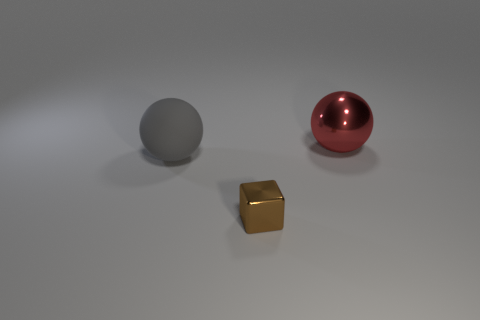Add 2 matte objects. How many objects exist? 5 Subtract all cubes. How many objects are left? 2 Add 3 small purple objects. How many small purple objects exist? 3 Subtract 0 cyan balls. How many objects are left? 3 Subtract all large gray spheres. Subtract all yellow metal spheres. How many objects are left? 2 Add 3 large red metallic things. How many large red metallic things are left? 4 